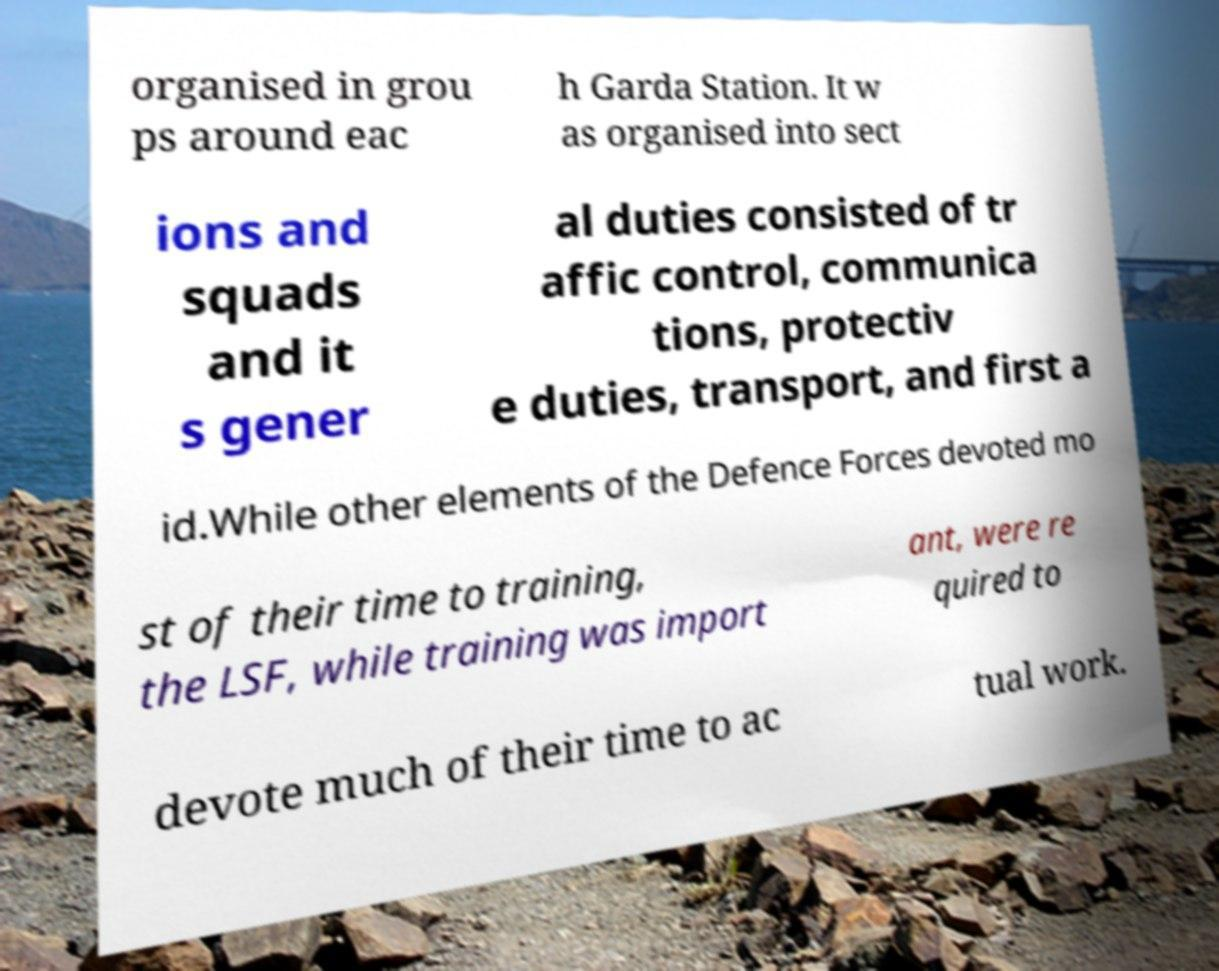Can you read and provide the text displayed in the image?This photo seems to have some interesting text. Can you extract and type it out for me? organised in grou ps around eac h Garda Station. It w as organised into sect ions and squads and it s gener al duties consisted of tr affic control, communica tions, protectiv e duties, transport, and first a id.While other elements of the Defence Forces devoted mo st of their time to training, the LSF, while training was import ant, were re quired to devote much of their time to ac tual work. 